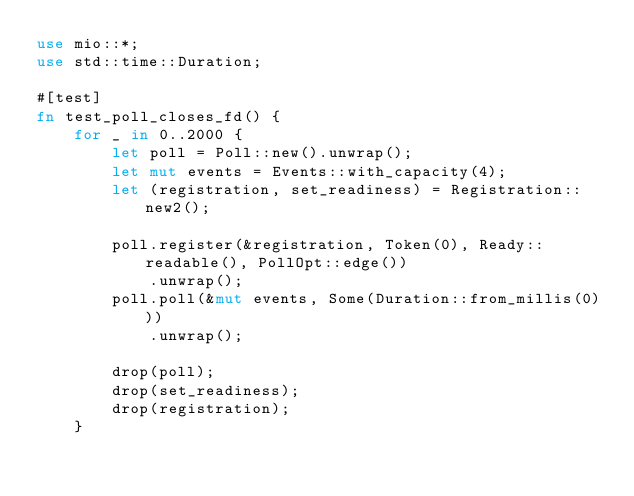Convert code to text. <code><loc_0><loc_0><loc_500><loc_500><_Rust_>use mio::*;
use std::time::Duration;

#[test]
fn test_poll_closes_fd() {
    for _ in 0..2000 {
        let poll = Poll::new().unwrap();
        let mut events = Events::with_capacity(4);
        let (registration, set_readiness) = Registration::new2();

        poll.register(&registration, Token(0), Ready::readable(), PollOpt::edge())
            .unwrap();
        poll.poll(&mut events, Some(Duration::from_millis(0)))
            .unwrap();

        drop(poll);
        drop(set_readiness);
        drop(registration);
    }</code> 